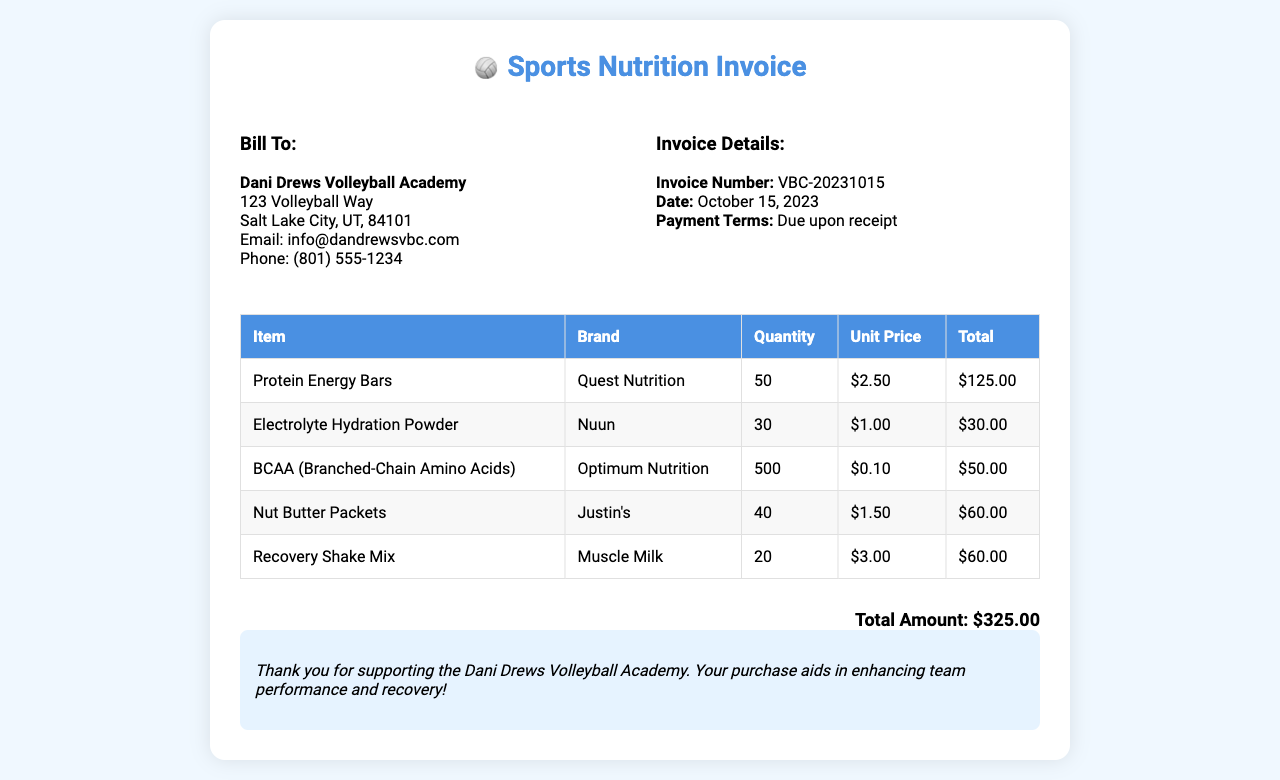what is the invoice number? The invoice number is listed in the invoice details section, which states "Invoice Number: VBC-20231015."
Answer: VBC-20231015 what is the total amount? The total amount is provided at the bottom of the invoice, stating "Total Amount: $325.00."
Answer: $325.00 who is the client? The client information section specifies that the bill is to "Dani Drews Volleyball Academy."
Answer: Dani Drews Volleyball Academy how many Protein Energy Bars were purchased? The table lists "Protein Energy Bars" with a quantity of 50 under the quantity column.
Answer: 50 what is the date of the invoice? The date is mentioned in the invoice details, which says "Date: October 15, 2023."
Answer: October 15, 2023 which item has the highest unit price? Reviewing the unit prices in the table shows that "Recovery Shake Mix" has the highest unit price of $3.00.
Answer: Recovery Shake Mix how many Nut Butter Packets were ordered? The quantity for "Nut Butter Packets" is mentioned in the table as 40.
Answer: 40 what is the brand of the BCAA? The table indicates that the brand for BCAA is "Optimum Nutrition."
Answer: Optimum Nutrition what is noted in the messages section? The notes section expresses gratitude for support and mentions enhancing team performance and recovery.
Answer: Thank you for supporting the Dani Drews Volleyball Academy 